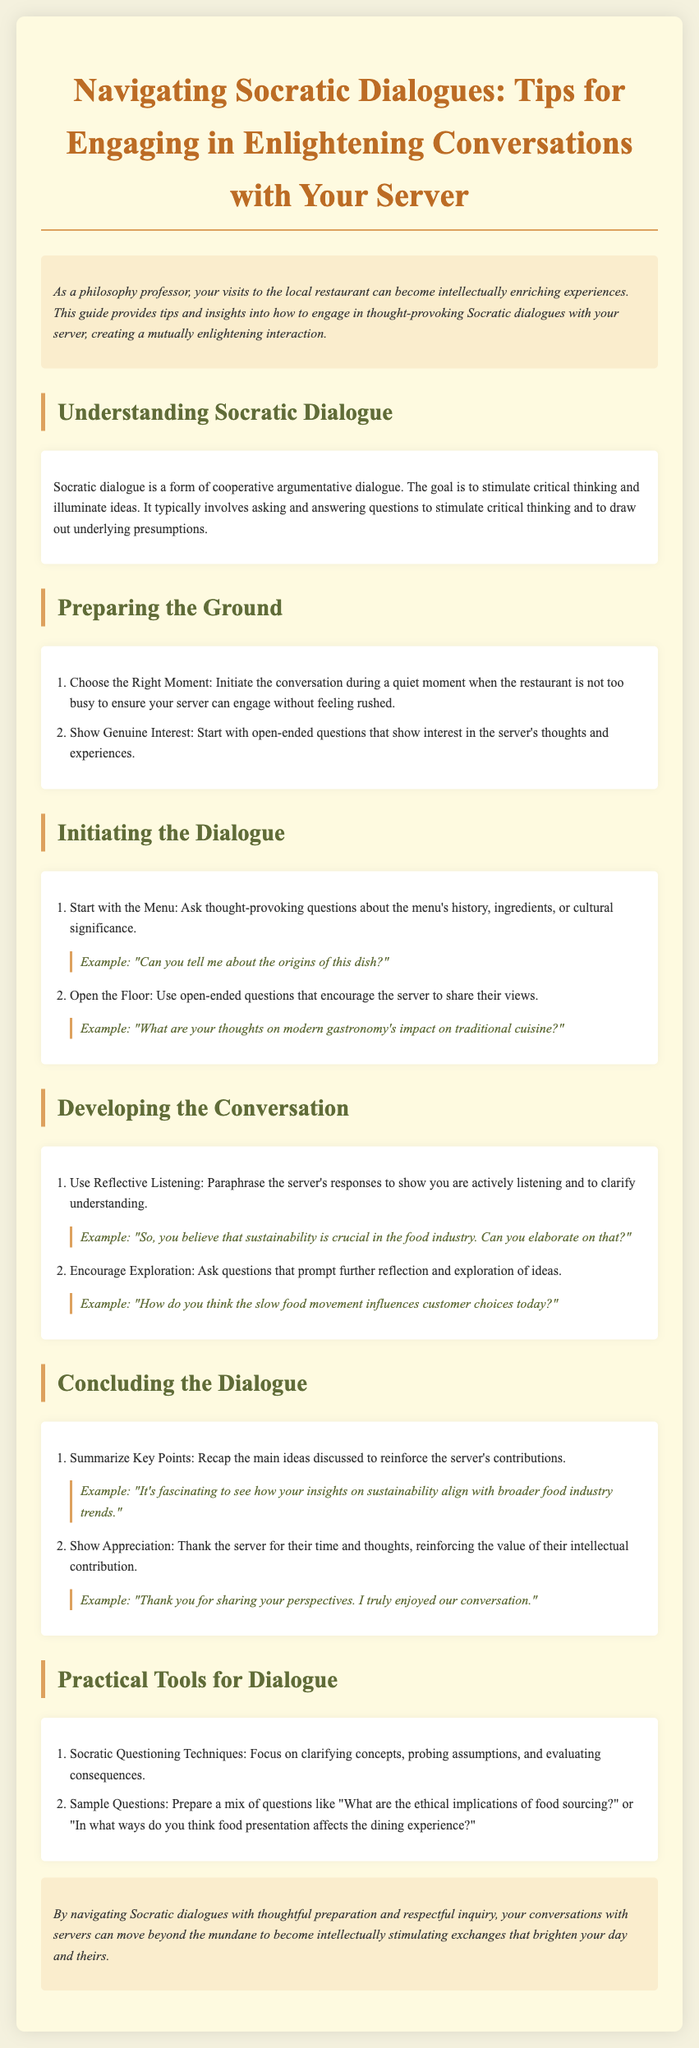What is the title of the document? The title is prominently displayed at the top of the document.
Answer: Navigating Socratic Dialogues: Tips for Engaging in Enlightening Conversations with Your Server What is one technique mentioned for developing conversation? This information can be found under the "Developing the Conversation" section of the guide.
Answer: Use Reflective Listening How many tips are provided under "Preparing the Ground"? The number of tips can be counted in the listed section of the document.
Answer: 2 What should you do to show appreciation at the end of the dialogue? This can be found in the "Concluding the Dialogue" section, highlighting what to do after a discussion.
Answer: Thank the server for their time and thoughts What is an example of an open-ended question to ask your server? This question requires finding a specific example in the section about initiating dialogue.
Answer: What are your thoughts on modern gastronomy's impact on traditional cuisine? What is the purpose of Socratic dialogue as described in the document? The goal of Socratic dialogue is outlined in the "Understanding Socratic Dialogue" section.
Answer: Stimulate critical thinking How should you summarize dialogue contributions? This method is provided in the "Concluding the Dialogue" section, stating how to reflect on the discussion.
Answer: Summarize Key Points What background color is used for the introduction section? This information pertains to the visual design elements used in the document layout.
Answer: #faedcd 